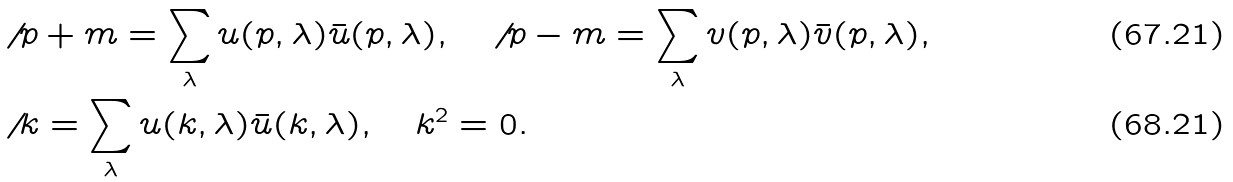<formula> <loc_0><loc_0><loc_500><loc_500>& \not \, { p } + m = \sum _ { \lambda } u ( p , \lambda ) \bar { u } ( p , \lambda ) , \quad \not \, { p } - m = \sum _ { \lambda } v ( p , \lambda ) \bar { v } ( p , \lambda ) , \\ & \not \, { k } = \sum _ { \lambda } u ( k , \lambda ) \bar { u } ( k , \lambda ) , \quad k ^ { 2 } = 0 .</formula> 